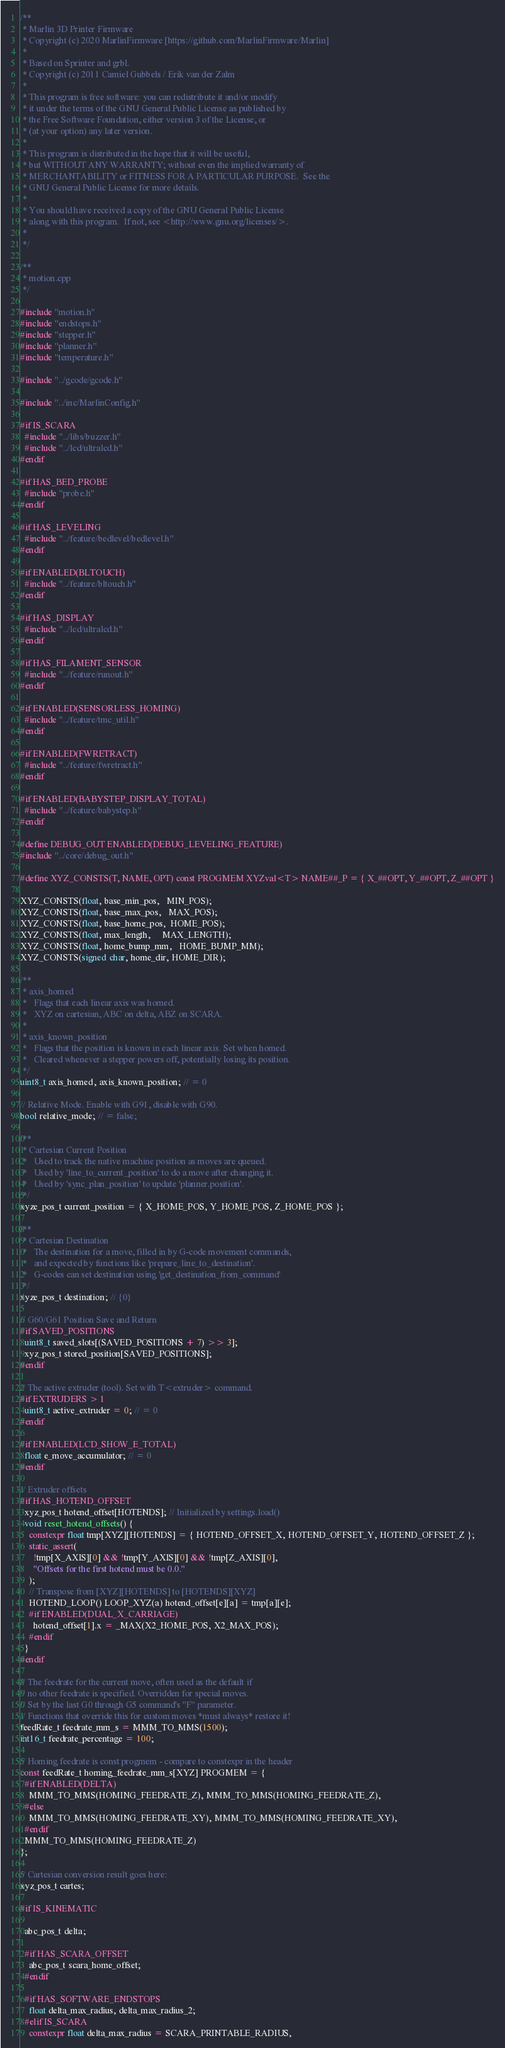<code> <loc_0><loc_0><loc_500><loc_500><_C++_>/**
 * Marlin 3D Printer Firmware
 * Copyright (c) 2020 MarlinFirmware [https://github.com/MarlinFirmware/Marlin]
 *
 * Based on Sprinter and grbl.
 * Copyright (c) 2011 Camiel Gubbels / Erik van der Zalm
 *
 * This program is free software: you can redistribute it and/or modify
 * it under the terms of the GNU General Public License as published by
 * the Free Software Foundation, either version 3 of the License, or
 * (at your option) any later version.
 *
 * This program is distributed in the hope that it will be useful,
 * but WITHOUT ANY WARRANTY; without even the implied warranty of
 * MERCHANTABILITY or FITNESS FOR A PARTICULAR PURPOSE.  See the
 * GNU General Public License for more details.
 *
 * You should have received a copy of the GNU General Public License
 * along with this program.  If not, see <http://www.gnu.org/licenses/>.
 *
 */

/**
 * motion.cpp
 */

#include "motion.h"
#include "endstops.h"
#include "stepper.h"
#include "planner.h"
#include "temperature.h"

#include "../gcode/gcode.h"

#include "../inc/MarlinConfig.h"

#if IS_SCARA
  #include "../libs/buzzer.h"
  #include "../lcd/ultralcd.h"
#endif

#if HAS_BED_PROBE
  #include "probe.h"
#endif

#if HAS_LEVELING
  #include "../feature/bedlevel/bedlevel.h"
#endif

#if ENABLED(BLTOUCH)
  #include "../feature/bltouch.h"
#endif

#if HAS_DISPLAY
  #include "../lcd/ultralcd.h"
#endif

#if HAS_FILAMENT_SENSOR
  #include "../feature/runout.h"
#endif

#if ENABLED(SENSORLESS_HOMING)
  #include "../feature/tmc_util.h"
#endif

#if ENABLED(FWRETRACT)
  #include "../feature/fwretract.h"
#endif

#if ENABLED(BABYSTEP_DISPLAY_TOTAL)
  #include "../feature/babystep.h"
#endif

#define DEBUG_OUT ENABLED(DEBUG_LEVELING_FEATURE)
#include "../core/debug_out.h"

#define XYZ_CONSTS(T, NAME, OPT) const PROGMEM XYZval<T> NAME##_P = { X_##OPT, Y_##OPT, Z_##OPT }

XYZ_CONSTS(float, base_min_pos,   MIN_POS);
XYZ_CONSTS(float, base_max_pos,   MAX_POS);
XYZ_CONSTS(float, base_home_pos,  HOME_POS);
XYZ_CONSTS(float, max_length,     MAX_LENGTH);
XYZ_CONSTS(float, home_bump_mm,   HOME_BUMP_MM);
XYZ_CONSTS(signed char, home_dir, HOME_DIR);

/**
 * axis_homed
 *   Flags that each linear axis was homed.
 *   XYZ on cartesian, ABC on delta, ABZ on SCARA.
 *
 * axis_known_position
 *   Flags that the position is known in each linear axis. Set when homed.
 *   Cleared whenever a stepper powers off, potentially losing its position.
 */
uint8_t axis_homed, axis_known_position; // = 0

// Relative Mode. Enable with G91, disable with G90.
bool relative_mode; // = false;

/**
 * Cartesian Current Position
 *   Used to track the native machine position as moves are queued.
 *   Used by 'line_to_current_position' to do a move after changing it.
 *   Used by 'sync_plan_position' to update 'planner.position'.
 */
xyze_pos_t current_position = { X_HOME_POS, Y_HOME_POS, Z_HOME_POS };

/**
 * Cartesian Destination
 *   The destination for a move, filled in by G-code movement commands,
 *   and expected by functions like 'prepare_line_to_destination'.
 *   G-codes can set destination using 'get_destination_from_command'
 */
xyze_pos_t destination; // {0}

// G60/G61 Position Save and Return
#if SAVED_POSITIONS
  uint8_t saved_slots[(SAVED_POSITIONS + 7) >> 3];
  xyz_pos_t stored_position[SAVED_POSITIONS];
#endif

// The active extruder (tool). Set with T<extruder> command.
#if EXTRUDERS > 1
  uint8_t active_extruder = 0; // = 0
#endif

#if ENABLED(LCD_SHOW_E_TOTAL)
  float e_move_accumulator; // = 0
#endif

// Extruder offsets
#if HAS_HOTEND_OFFSET
  xyz_pos_t hotend_offset[HOTENDS]; // Initialized by settings.load()
  void reset_hotend_offsets() {
    constexpr float tmp[XYZ][HOTENDS] = { HOTEND_OFFSET_X, HOTEND_OFFSET_Y, HOTEND_OFFSET_Z };
    static_assert(
      !tmp[X_AXIS][0] && !tmp[Y_AXIS][0] && !tmp[Z_AXIS][0],
      "Offsets for the first hotend must be 0.0."
    );
    // Transpose from [XYZ][HOTENDS] to [HOTENDS][XYZ]
    HOTEND_LOOP() LOOP_XYZ(a) hotend_offset[e][a] = tmp[a][e];
    #if ENABLED(DUAL_X_CARRIAGE)
      hotend_offset[1].x = _MAX(X2_HOME_POS, X2_MAX_POS);
    #endif
  }
#endif

// The feedrate for the current move, often used as the default if
// no other feedrate is specified. Overridden for special moves.
// Set by the last G0 through G5 command's "F" parameter.
// Functions that override this for custom moves *must always* restore it!
feedRate_t feedrate_mm_s = MMM_TO_MMS(1500);
int16_t feedrate_percentage = 100;

// Homing feedrate is const progmem - compare to constexpr in the header
const feedRate_t homing_feedrate_mm_s[XYZ] PROGMEM = {
  #if ENABLED(DELTA)
    MMM_TO_MMS(HOMING_FEEDRATE_Z), MMM_TO_MMS(HOMING_FEEDRATE_Z),
  #else
    MMM_TO_MMS(HOMING_FEEDRATE_XY), MMM_TO_MMS(HOMING_FEEDRATE_XY),
  #endif
  MMM_TO_MMS(HOMING_FEEDRATE_Z)
};

// Cartesian conversion result goes here:
xyz_pos_t cartes;

#if IS_KINEMATIC

  abc_pos_t delta;

  #if HAS_SCARA_OFFSET
    abc_pos_t scara_home_offset;
  #endif

  #if HAS_SOFTWARE_ENDSTOPS
    float delta_max_radius, delta_max_radius_2;
  #elif IS_SCARA
    constexpr float delta_max_radius = SCARA_PRINTABLE_RADIUS,</code> 